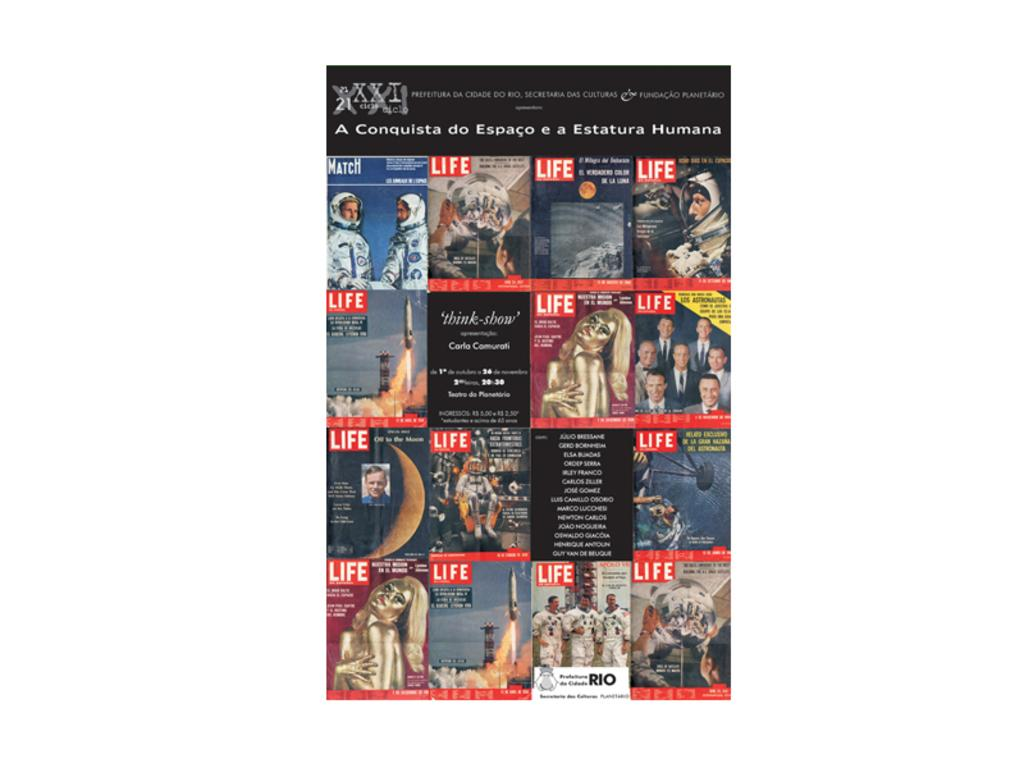<image>
Relay a brief, clear account of the picture shown. A poster in Spanish with various LIFE magazine covers on it. 